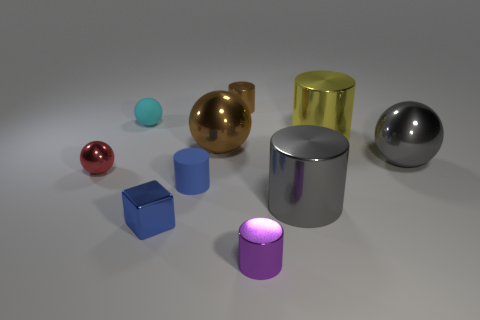What is the size of the matte thing that is the same color as the small block?
Your response must be concise. Small. There is a gray shiny object behind the tiny blue matte thing; how big is it?
Provide a succinct answer. Large. Are there fewer shiny objects behind the gray cylinder than shiny balls behind the cyan matte ball?
Your answer should be compact. No. What color is the shiny cube?
Offer a terse response. Blue. Is there another matte cylinder that has the same color as the matte cylinder?
Offer a very short reply. No. What is the shape of the large thing that is to the right of the yellow thing that is behind the tiny shiny cylinder in front of the blue block?
Make the answer very short. Sphere. What is the material of the blue thing in front of the small blue cylinder?
Ensure brevity in your answer.  Metal. What is the size of the brown thing behind the big shiny cylinder that is behind the tiny blue thing behind the block?
Provide a short and direct response. Small. Do the brown cylinder and the metallic ball left of the tiny cyan object have the same size?
Provide a short and direct response. Yes. What color is the tiny rubber thing on the right side of the tiny metal block?
Your answer should be very brief. Blue. 